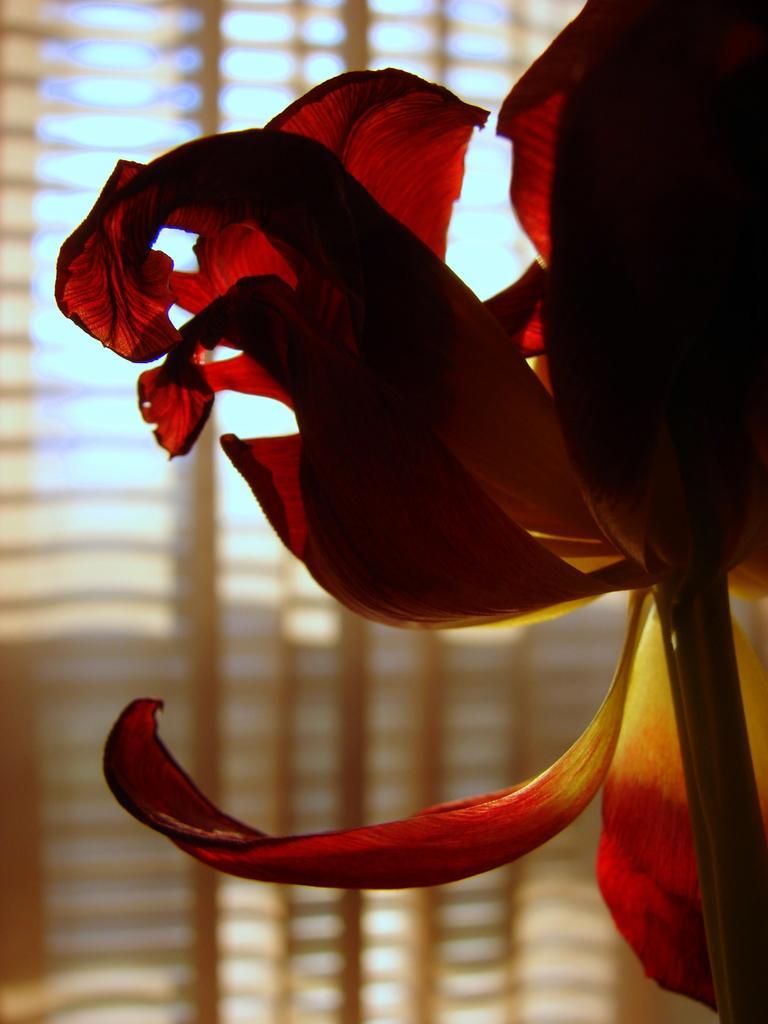Can you describe this image briefly? This image is taken indoors. In the background there is a window and there is a window blind. On the right side of the image there is a flower. 